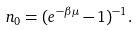Convert formula to latex. <formula><loc_0><loc_0><loc_500><loc_500>n _ { 0 } = ( e ^ { - \beta \mu } - 1 ) ^ { - 1 } .</formula> 